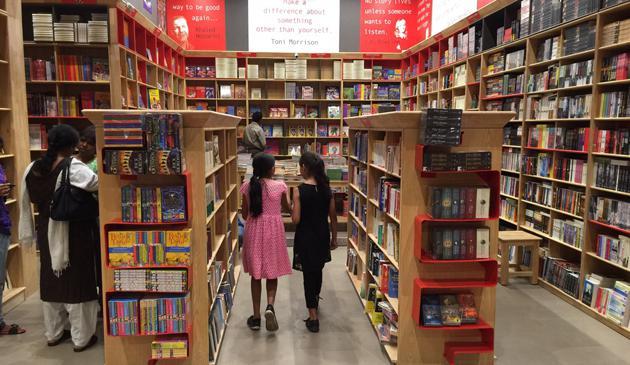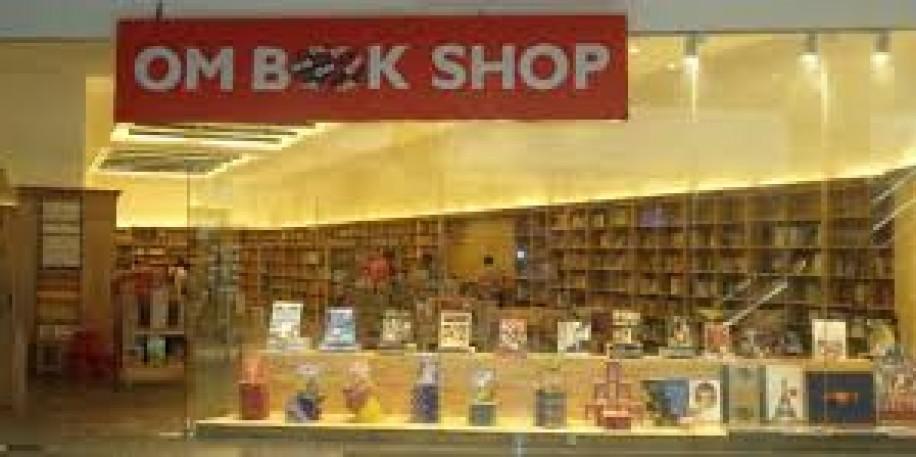The first image is the image on the left, the second image is the image on the right. For the images displayed, is the sentence "A back-turned person wearing something pinkish stands in the aisle at the very center of the bookstore, with tall shelves surrounding them." factually correct? Answer yes or no. Yes. 